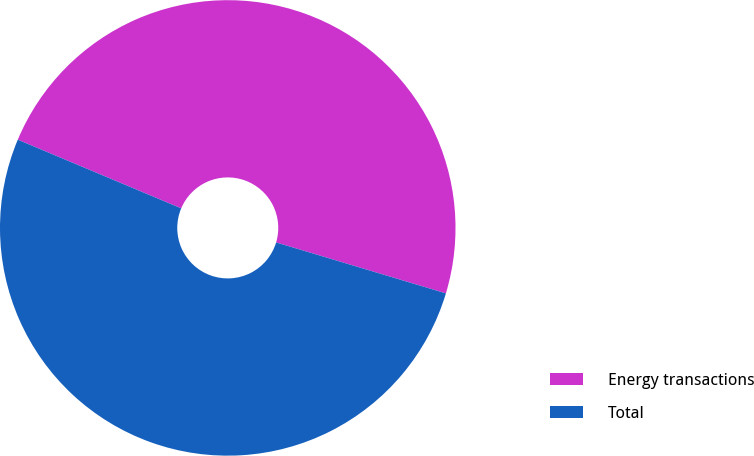Convert chart. <chart><loc_0><loc_0><loc_500><loc_500><pie_chart><fcel>Energy transactions<fcel>Total<nl><fcel>48.31%<fcel>51.69%<nl></chart> 